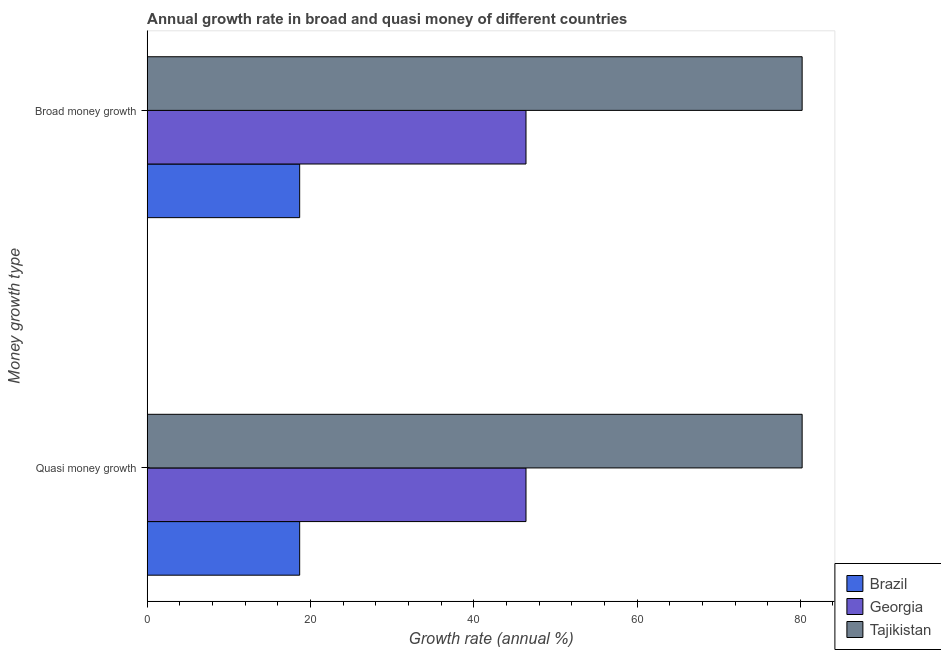How many groups of bars are there?
Keep it short and to the point. 2. Are the number of bars per tick equal to the number of legend labels?
Provide a succinct answer. Yes. Are the number of bars on each tick of the Y-axis equal?
Provide a short and direct response. Yes. How many bars are there on the 1st tick from the bottom?
Your answer should be compact. 3. What is the label of the 2nd group of bars from the top?
Give a very brief answer. Quasi money growth. What is the annual growth rate in broad money in Brazil?
Make the answer very short. 18.68. Across all countries, what is the maximum annual growth rate in broad money?
Provide a short and direct response. 80.22. Across all countries, what is the minimum annual growth rate in broad money?
Ensure brevity in your answer.  18.68. In which country was the annual growth rate in quasi money maximum?
Offer a very short reply. Tajikistan. What is the total annual growth rate in broad money in the graph?
Offer a very short reply. 145.3. What is the difference between the annual growth rate in quasi money in Tajikistan and that in Georgia?
Make the answer very short. 33.82. What is the difference between the annual growth rate in broad money in Brazil and the annual growth rate in quasi money in Georgia?
Offer a terse response. -27.72. What is the average annual growth rate in quasi money per country?
Make the answer very short. 48.43. What is the difference between the annual growth rate in quasi money and annual growth rate in broad money in Brazil?
Offer a terse response. 0. In how many countries, is the annual growth rate in quasi money greater than 64 %?
Offer a very short reply. 1. What is the ratio of the annual growth rate in broad money in Georgia to that in Brazil?
Provide a short and direct response. 2.48. What does the 2nd bar from the top in Quasi money growth represents?
Your answer should be very brief. Georgia. How many countries are there in the graph?
Give a very brief answer. 3. What is the difference between two consecutive major ticks on the X-axis?
Your answer should be very brief. 20. Are the values on the major ticks of X-axis written in scientific E-notation?
Your response must be concise. No. Does the graph contain any zero values?
Your answer should be compact. No. Where does the legend appear in the graph?
Make the answer very short. Bottom right. How many legend labels are there?
Your response must be concise. 3. What is the title of the graph?
Keep it short and to the point. Annual growth rate in broad and quasi money of different countries. What is the label or title of the X-axis?
Offer a terse response. Growth rate (annual %). What is the label or title of the Y-axis?
Give a very brief answer. Money growth type. What is the Growth rate (annual %) of Brazil in Quasi money growth?
Provide a succinct answer. 18.68. What is the Growth rate (annual %) of Georgia in Quasi money growth?
Keep it short and to the point. 46.4. What is the Growth rate (annual %) in Tajikistan in Quasi money growth?
Provide a succinct answer. 80.22. What is the Growth rate (annual %) of Brazil in Broad money growth?
Provide a succinct answer. 18.68. What is the Growth rate (annual %) in Georgia in Broad money growth?
Your answer should be compact. 46.4. What is the Growth rate (annual %) in Tajikistan in Broad money growth?
Ensure brevity in your answer.  80.22. Across all Money growth type, what is the maximum Growth rate (annual %) in Brazil?
Offer a very short reply. 18.68. Across all Money growth type, what is the maximum Growth rate (annual %) in Georgia?
Provide a short and direct response. 46.4. Across all Money growth type, what is the maximum Growth rate (annual %) of Tajikistan?
Make the answer very short. 80.22. Across all Money growth type, what is the minimum Growth rate (annual %) of Brazil?
Keep it short and to the point. 18.68. Across all Money growth type, what is the minimum Growth rate (annual %) in Georgia?
Your answer should be compact. 46.4. Across all Money growth type, what is the minimum Growth rate (annual %) of Tajikistan?
Ensure brevity in your answer.  80.22. What is the total Growth rate (annual %) in Brazil in the graph?
Your answer should be compact. 37.36. What is the total Growth rate (annual %) of Georgia in the graph?
Ensure brevity in your answer.  92.8. What is the total Growth rate (annual %) of Tajikistan in the graph?
Provide a succinct answer. 160.44. What is the difference between the Growth rate (annual %) of Georgia in Quasi money growth and that in Broad money growth?
Ensure brevity in your answer.  0. What is the difference between the Growth rate (annual %) in Tajikistan in Quasi money growth and that in Broad money growth?
Give a very brief answer. 0. What is the difference between the Growth rate (annual %) of Brazil in Quasi money growth and the Growth rate (annual %) of Georgia in Broad money growth?
Give a very brief answer. -27.72. What is the difference between the Growth rate (annual %) in Brazil in Quasi money growth and the Growth rate (annual %) in Tajikistan in Broad money growth?
Give a very brief answer. -61.54. What is the difference between the Growth rate (annual %) in Georgia in Quasi money growth and the Growth rate (annual %) in Tajikistan in Broad money growth?
Your answer should be compact. -33.82. What is the average Growth rate (annual %) in Brazil per Money growth type?
Ensure brevity in your answer.  18.68. What is the average Growth rate (annual %) of Georgia per Money growth type?
Your response must be concise. 46.4. What is the average Growth rate (annual %) in Tajikistan per Money growth type?
Your answer should be compact. 80.22. What is the difference between the Growth rate (annual %) in Brazil and Growth rate (annual %) in Georgia in Quasi money growth?
Your response must be concise. -27.72. What is the difference between the Growth rate (annual %) in Brazil and Growth rate (annual %) in Tajikistan in Quasi money growth?
Make the answer very short. -61.54. What is the difference between the Growth rate (annual %) in Georgia and Growth rate (annual %) in Tajikistan in Quasi money growth?
Offer a very short reply. -33.82. What is the difference between the Growth rate (annual %) in Brazil and Growth rate (annual %) in Georgia in Broad money growth?
Keep it short and to the point. -27.72. What is the difference between the Growth rate (annual %) of Brazil and Growth rate (annual %) of Tajikistan in Broad money growth?
Keep it short and to the point. -61.54. What is the difference between the Growth rate (annual %) in Georgia and Growth rate (annual %) in Tajikistan in Broad money growth?
Offer a very short reply. -33.82. What is the ratio of the Growth rate (annual %) of Georgia in Quasi money growth to that in Broad money growth?
Offer a very short reply. 1. What is the ratio of the Growth rate (annual %) in Tajikistan in Quasi money growth to that in Broad money growth?
Your answer should be very brief. 1. What is the difference between the highest and the second highest Growth rate (annual %) of Brazil?
Your answer should be very brief. 0. What is the difference between the highest and the second highest Growth rate (annual %) of Georgia?
Make the answer very short. 0. What is the difference between the highest and the second highest Growth rate (annual %) of Tajikistan?
Your response must be concise. 0. What is the difference between the highest and the lowest Growth rate (annual %) in Georgia?
Provide a short and direct response. 0. What is the difference between the highest and the lowest Growth rate (annual %) of Tajikistan?
Your answer should be very brief. 0. 